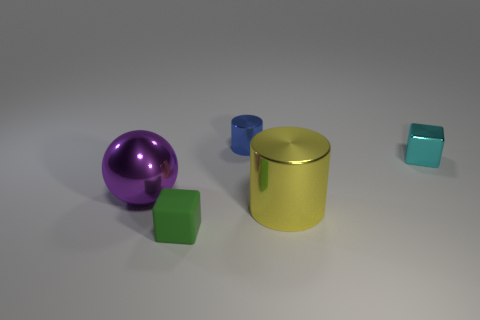What is the shape of the large purple object that is made of the same material as the large cylinder?
Give a very brief answer. Sphere. Is the size of the cyan shiny cube the same as the green matte cube?
Your answer should be very brief. Yes. Does the cube that is to the right of the tiny green block have the same material as the small blue cylinder?
Offer a very short reply. Yes. Is there anything else that has the same material as the small cyan object?
Make the answer very short. Yes. There is a block that is to the right of the tiny block that is to the left of the small cyan thing; what number of small objects are behind it?
Provide a succinct answer. 1. Do the tiny metal thing that is on the right side of the small blue thing and the small blue thing have the same shape?
Offer a terse response. No. What number of things are large green metallic cylinders or metal cylinders in front of the cyan metal thing?
Offer a very short reply. 1. Is the number of cyan things that are in front of the small matte cube greater than the number of tiny red blocks?
Offer a terse response. No. Is the number of cyan metallic things that are left of the big cylinder the same as the number of cyan cubes that are behind the cyan cube?
Make the answer very short. Yes. Are there any small cylinders that are behind the cylinder that is behind the tiny cyan object?
Offer a very short reply. No. 